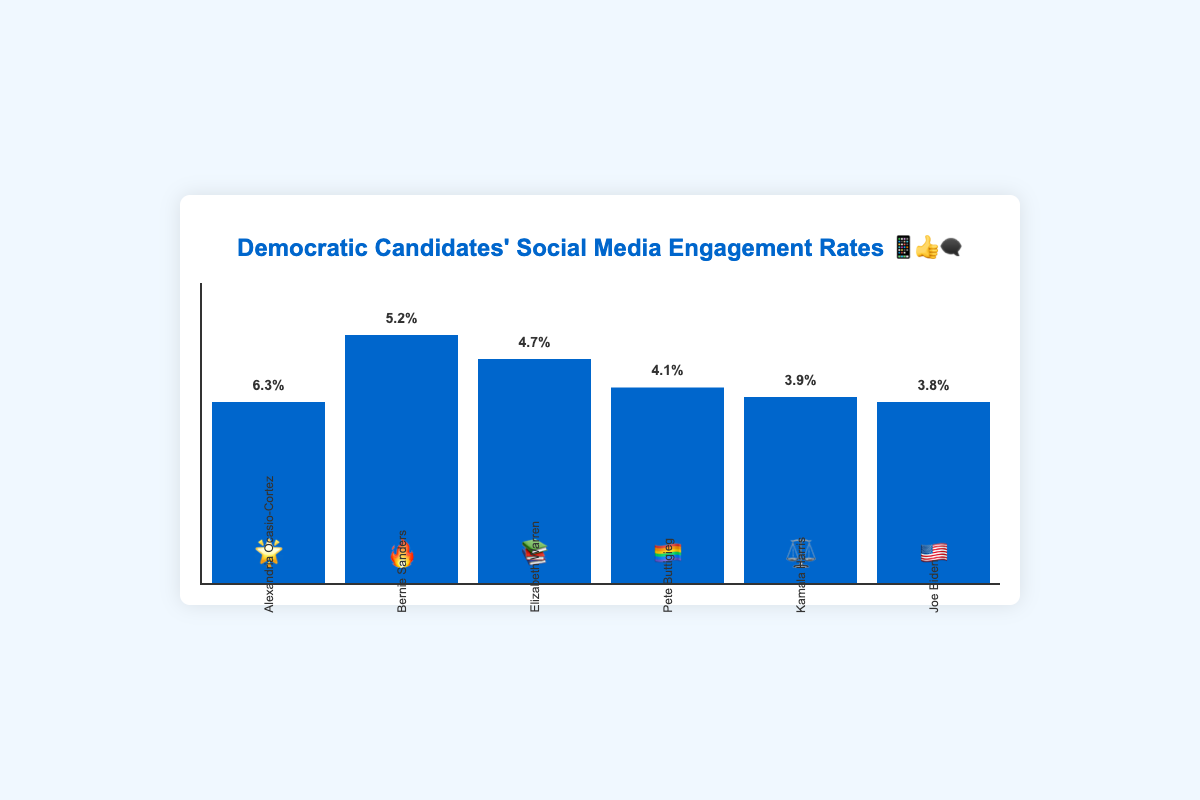What's the highest engagement rate, and which candidate does it belong to? The highest engagement rate can be identified by looking at the tallest bar in the chart. The tallest bar has an engagement rate of 6.3%. It belongs to Alexandria Ocasio-Cortez, represented by the emoji 🌟.
Answer: 6.3%, Alexandria Ocasio-Cortez Which candidate has a higher engagement rate, Joe Biden or Kamala Harris? To compare the engagement rates, we need to look at the bars for Joe Biden and Kamala Harris. Joe Biden has an engagement rate of 3.8%, and Kamala Harris has an engagement rate of 3.9%. Since 3.9% is higher than 3.8%, Kamala Harris has a higher engagement rate.
Answer: Kamala Harris What's the difference in engagement rates between Bernie Sanders and Pete Buttigieg? To find the difference, we subtract Pete Buttigieg's engagement rate (4.1%) from Bernie Sanders' engagement rate (5.2%). 5.2% - 4.1% = 1.1%.
Answer: 1.1% Calculate the average engagement rate of all the candidates. To calculate the average engagement rate, sum up all the engagement rates: 3.8% (Joe Biden) + 5.2% (Bernie Sanders) + 4.7% (Elizabeth Warren) + 4.1% (Pete Buttigieg) + 3.9% (Kamala Harris) + 6.3% (Alexandria Ocasio-Cortez) = 28%. Then, divide by the number of candidates, which is 6. 28% / 6 = 4.67%.
Answer: 4.67% Who has the lowest engagement rate, and what is that rate? The lowest engagement rate can be identified by looking at the shortest bar in the chart. The shortest bar has an engagement rate of 3.8%. It belongs to Joe Biden, represented by the emoji 🇺🇸.
Answer: 3.8%, Joe Biden Arrange the candidates in descending order of their engagement rates. To arrange the candidates, list them from the highest engagement rate to the lowest: Alexandria Ocasio-Cortez (6.3%), Bernie Sanders (5.2%), Elizabeth Warren (4.7%), Pete Buttigieg (4.1%), Kamala Harris (3.9%), Joe Biden (3.8%).
Answer: Alexandria Ocasio-Cortez, Bernie Sanders, Elizabeth Warren, Pete Buttigieg, Kamala Harris, Joe Biden How much higher is Alexandria Ocasio-Cortez's engagement rate compared to Elizabeth Warren's? Subtract Elizabeth Warren's engagement rate (4.7%) from Alexandria Ocasio-Cortez's engagement rate (6.3%). 6.3% - 4.7% = 1.6%.
Answer: 1.6% If the engagement rate were doubled for Pete Buttigieg, what would his new rate be? Pete Buttigieg's current engagement rate is 4.1%. If it were doubled, multiply 4.1% by 2. 4.1% * 2 = 8.2%.
Answer: 8.2% What's the median engagement rate of the candidates? To find the median, first arrange the engagement rates in ascending order: 3.8%, 3.9%, 4.1%, 4.7%, 5.2%, 6.3%. Since there are six data points, the median is the average of the third and fourth values: (4.1% + 4.7%) / 2 = 4.4%.
Answer: 4.4% 